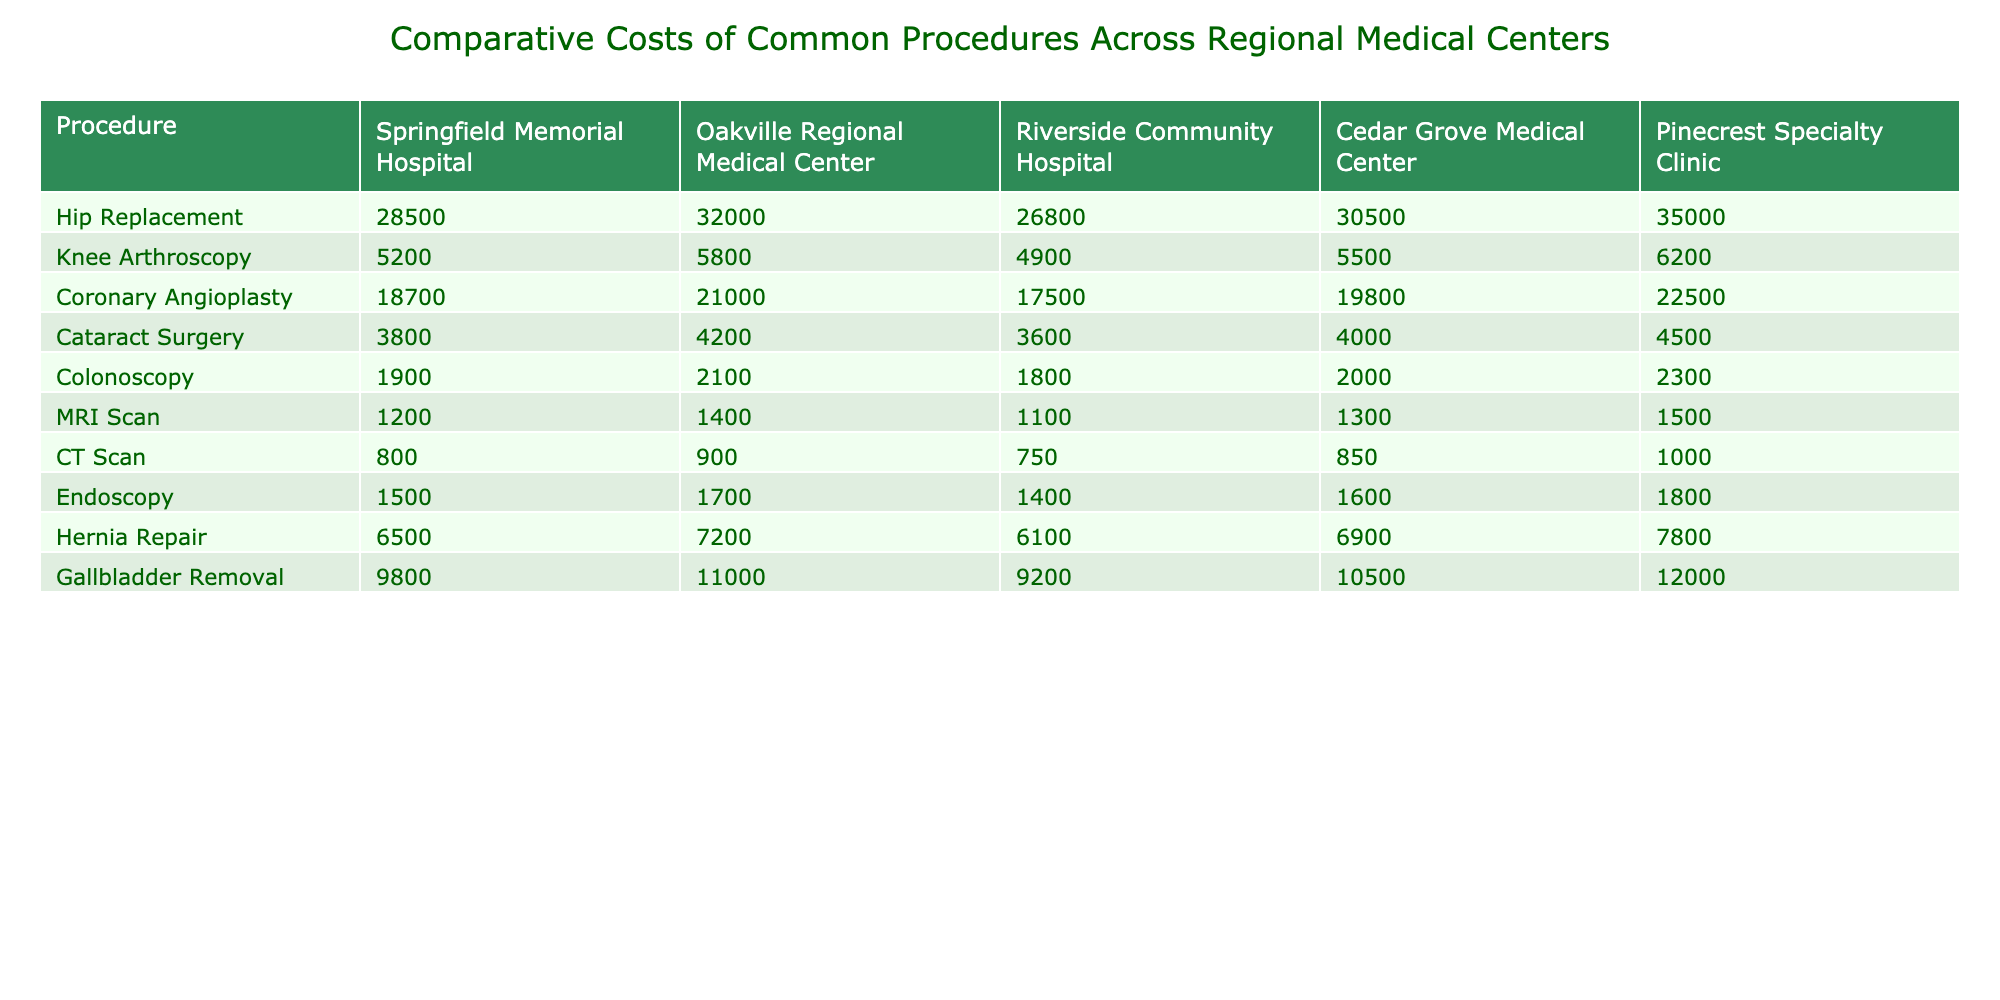What is the cost of Hip Replacement surgery at Riverside Community Hospital? The table indicates that the cost of Hip Replacement surgery at Riverside Community Hospital is listed directly under that category, showing $26,800.
Answer: $26,800 Which medical center has the highest cost for Cataract Surgery? By comparing the costs of Cataract Surgery across all medical centers, Oakville Regional Medical Center has the highest cost at $4,200.
Answer: $4,200 What is the average cost of an MRI Scan across all centers? To find the average, we add the costs of MRI Scans from each center: (1200 + 1400 + 1100 + 1300 + 1500) = 7500. Dividing by the number of centers (5), we get 7500 / 5 = 1500.
Answer: $1,500 Is the cost of Knee Arthroscopy at Pinecrest Specialty Clinic more than $6,000? The cost at Pinecrest Specialty Clinic for Knee Arthroscopy is $6,200, which is indeed more than $6,000. Thus, the answer is yes.
Answer: Yes Which procedure has the lowest cost at Riverside Community Hospital? By reviewing all the procedures listed for Riverside Community Hospital, the lowest cost is for Colonoscopy at $1,800.
Answer: Colonoscopy What is the total cost of Hernia Repair surgeries across all medical centers? Adding the costs for Hernia Repair: (6500 + 7200 + 6100 + 6900 + 7800) = 34600. Therefore, the total cost across all centers is $34,600.
Answer: $34,600 How much more expensive is Coronary Angioplasty at Pinecrest Specialty Clinic compared to Springfield Memorial Hospital? The cost of Coronary Angioplasty at Pinecrest is $22,500, while at Springfield Memorial Hospital, it's $18,700. The difference is 22500 - 18700 = $3,800.
Answer: $3,800 What is the procedure with the largest cost difference between the lowest and highest prices offered amongst the medical centers? Examining each procedure's maximum and minimum costs, Hip Replacement has the largest difference: $35,000 (Pinecrest) - $26,800 (Riverside) = $8,200.
Answer: Hip Replacement Which facility offers the cheapest colonoscopy and what is the cost? The table shows that Riverside Community Hospital has the cheapest Colonoscopy at $1,800.
Answer: $1,800 Are the costs for Gallbladder Removal at Oakville Regional Medical Center and Cedar Grove Medical Center equal? Comparing the costs, Oakville has $11,000 and Cedar Grove has $10,500. Since they are not equal, the answer is no.
Answer: No 